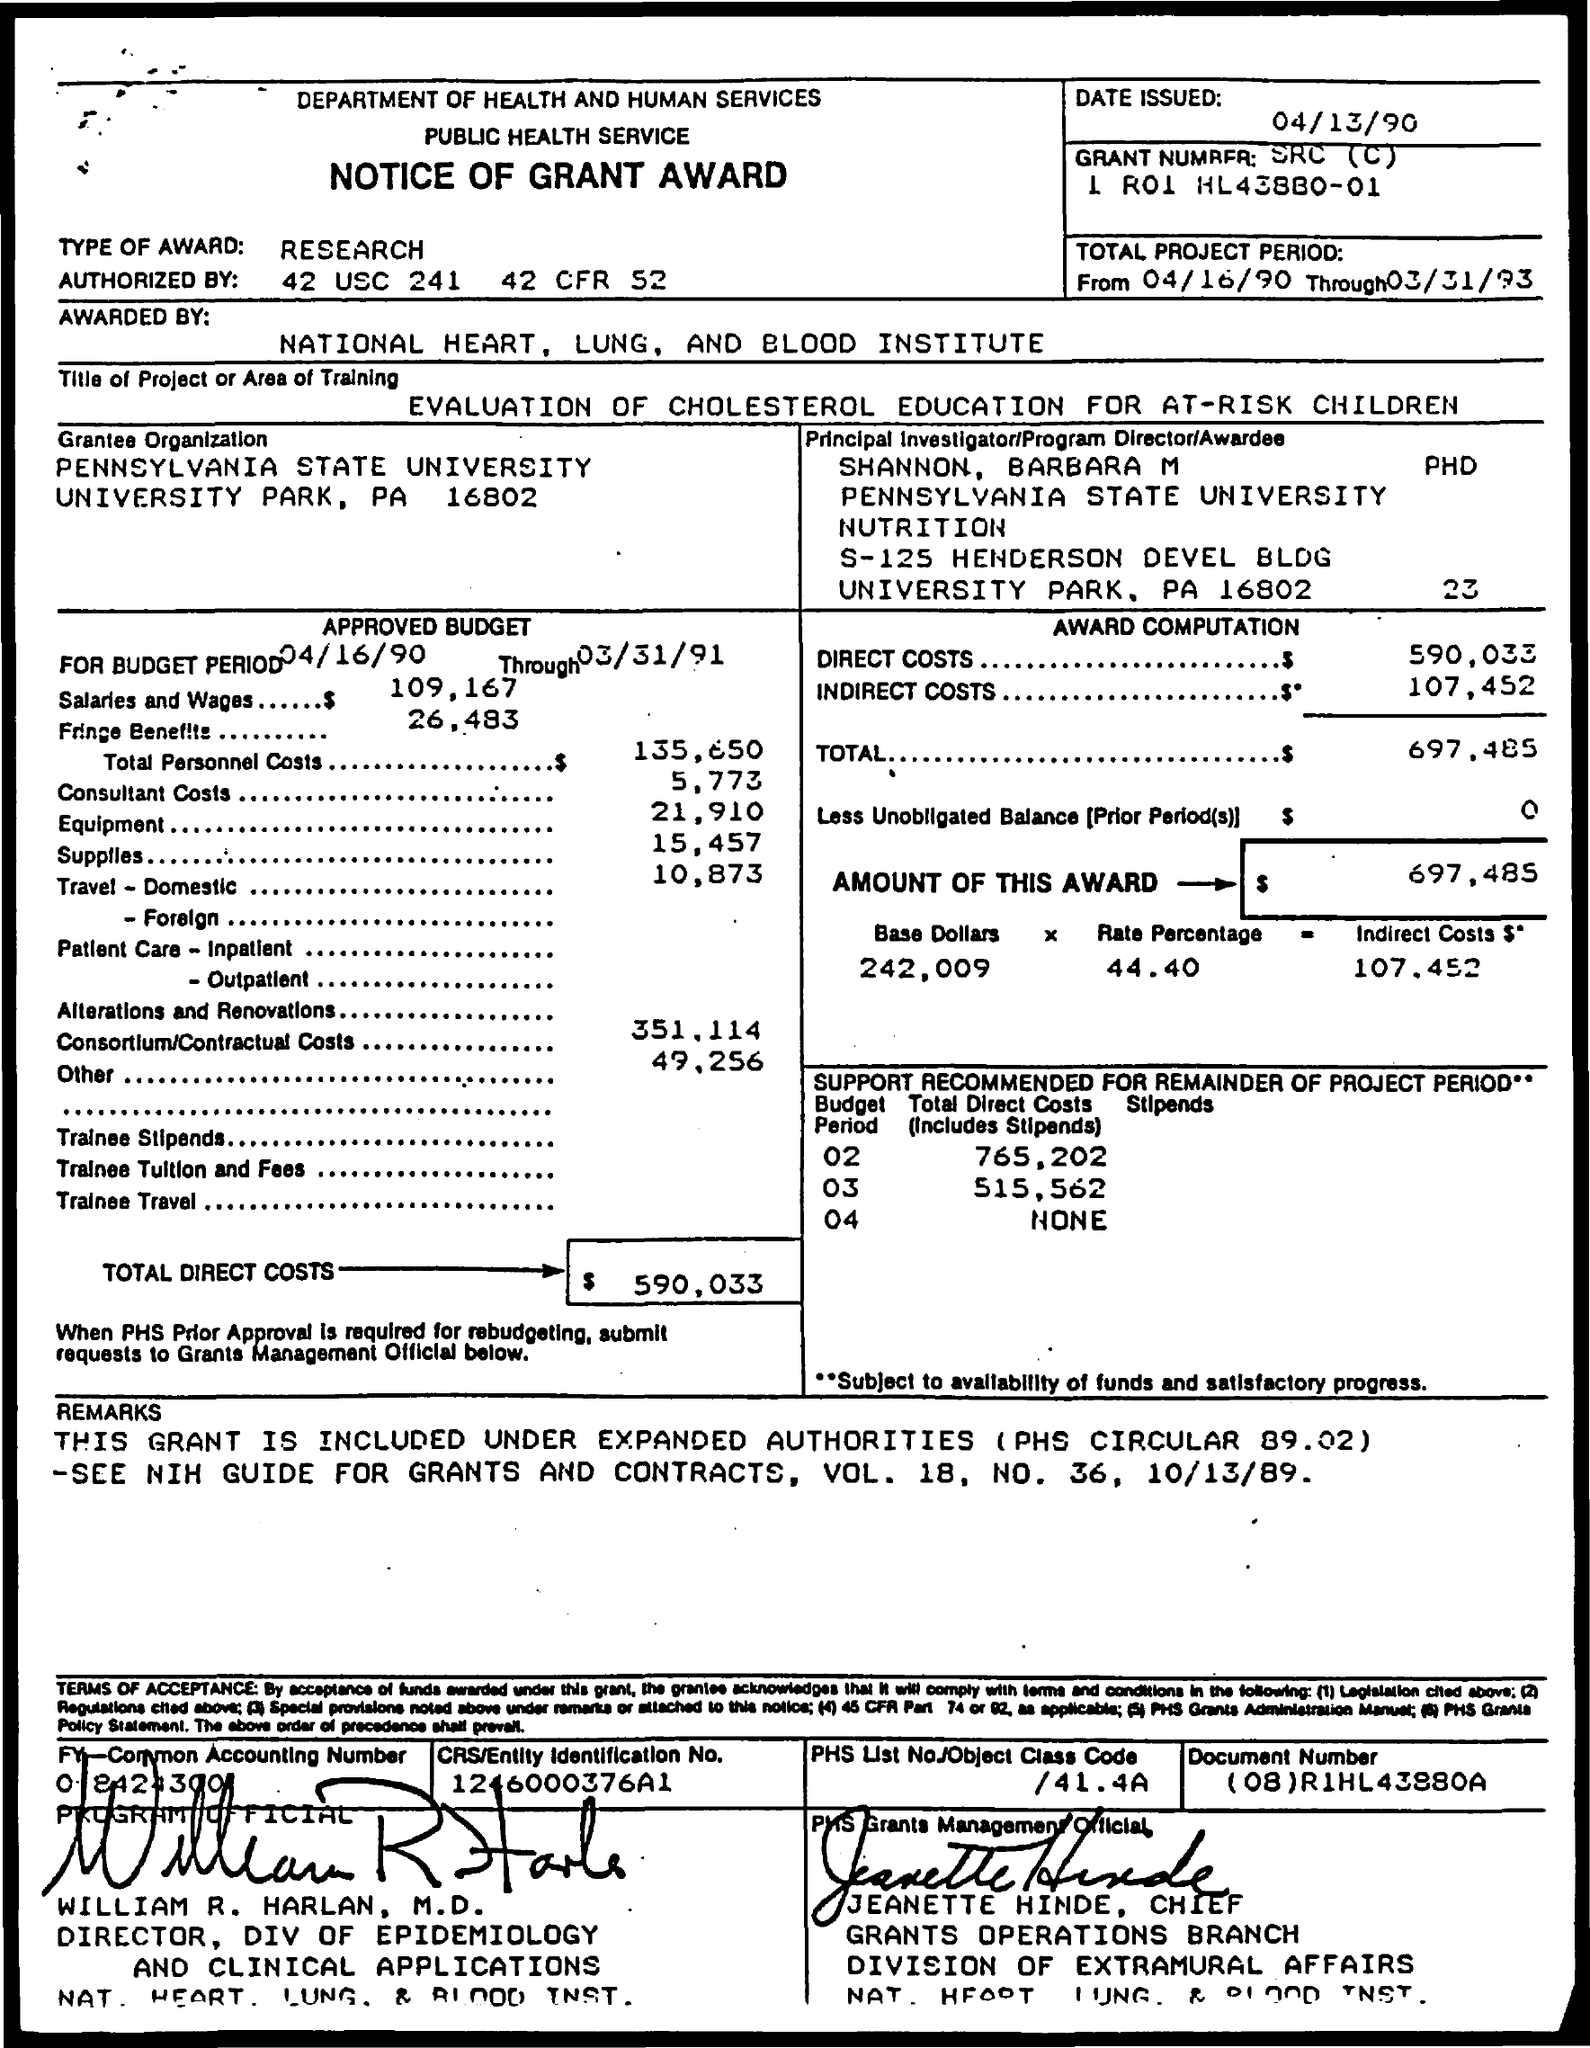Draw attention to some important aspects in this diagram. The amount of this award is $697,485. The total project period began on April 16, 1990 and ended on March 31, 1993. The authority to take action under 42 USC 241 and 42 CFR 52 is granted by the United States Code and Code of Federal Regulations. The type of award is a research award. The indirect costs of the project are estimated to be $107,452. 